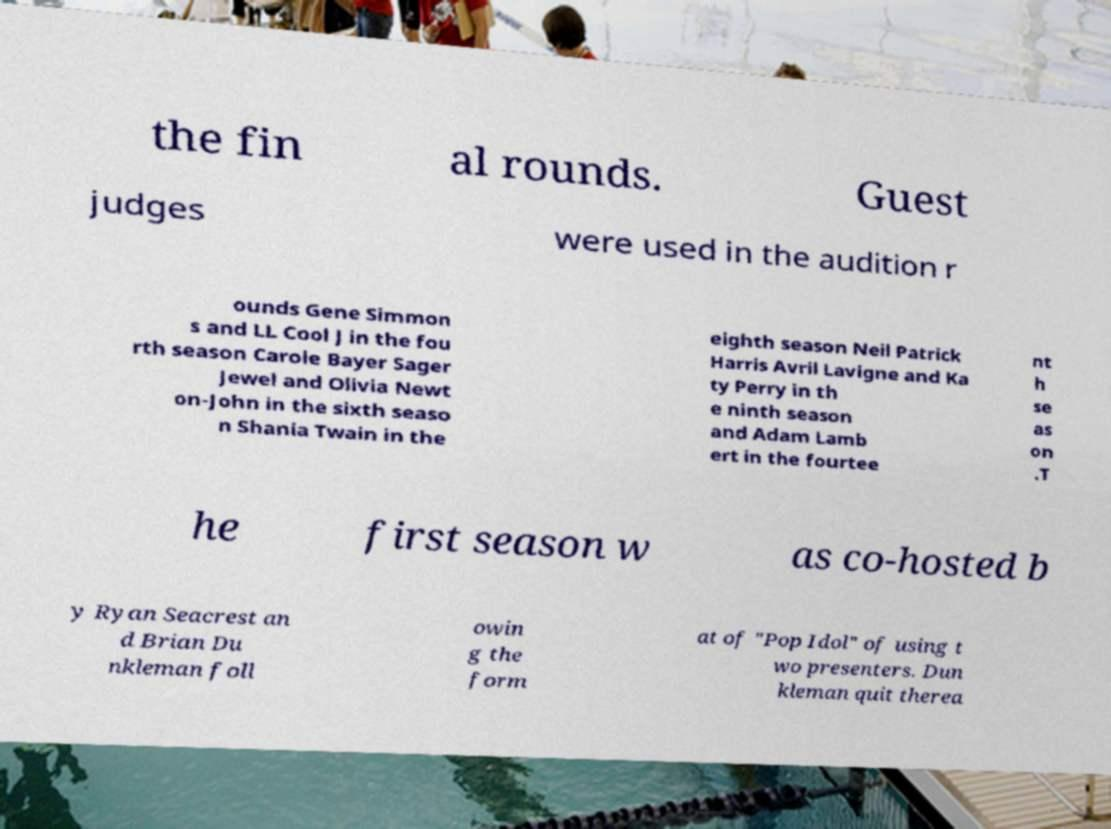Please identify and transcribe the text found in this image. the fin al rounds. Guest judges were used in the audition r ounds Gene Simmon s and LL Cool J in the fou rth season Carole Bayer Sager Jewel and Olivia Newt on-John in the sixth seaso n Shania Twain in the eighth season Neil Patrick Harris Avril Lavigne and Ka ty Perry in th e ninth season and Adam Lamb ert in the fourtee nt h se as on .T he first season w as co-hosted b y Ryan Seacrest an d Brian Du nkleman foll owin g the form at of "Pop Idol" of using t wo presenters. Dun kleman quit therea 